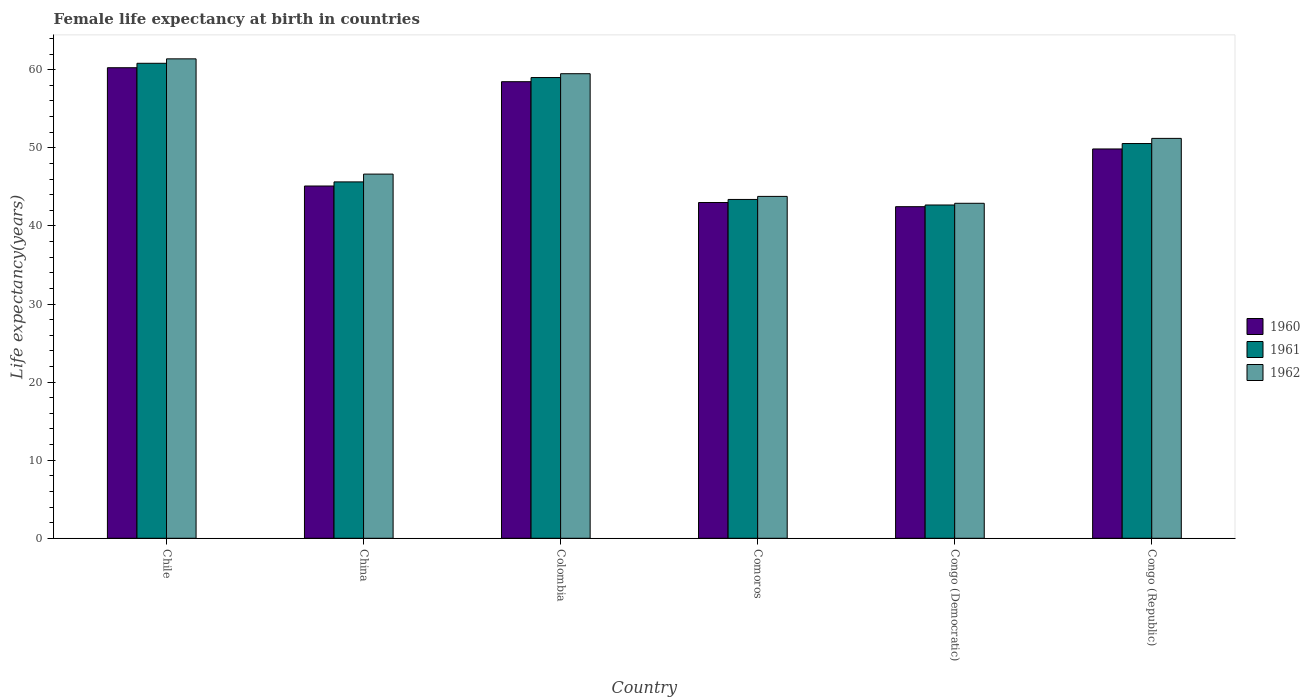How many groups of bars are there?
Make the answer very short. 6. How many bars are there on the 2nd tick from the right?
Provide a succinct answer. 3. What is the label of the 6th group of bars from the left?
Provide a short and direct response. Congo (Republic). What is the female life expectancy at birth in 1960 in Congo (Democratic)?
Provide a short and direct response. 42.47. Across all countries, what is the maximum female life expectancy at birth in 1961?
Offer a very short reply. 60.83. Across all countries, what is the minimum female life expectancy at birth in 1961?
Provide a short and direct response. 42.68. In which country was the female life expectancy at birth in 1960 maximum?
Your response must be concise. Chile. In which country was the female life expectancy at birth in 1962 minimum?
Your answer should be very brief. Congo (Democratic). What is the total female life expectancy at birth in 1962 in the graph?
Give a very brief answer. 305.42. What is the difference between the female life expectancy at birth in 1962 in China and that in Congo (Democratic)?
Offer a very short reply. 3.74. What is the difference between the female life expectancy at birth in 1962 in Comoros and the female life expectancy at birth in 1961 in Colombia?
Your answer should be compact. -15.22. What is the average female life expectancy at birth in 1960 per country?
Your answer should be compact. 49.86. What is the difference between the female life expectancy at birth of/in 1961 and female life expectancy at birth of/in 1960 in Comoros?
Give a very brief answer. 0.39. What is the ratio of the female life expectancy at birth in 1960 in Chile to that in China?
Provide a succinct answer. 1.34. Is the female life expectancy at birth in 1961 in Colombia less than that in Congo (Democratic)?
Make the answer very short. No. What is the difference between the highest and the second highest female life expectancy at birth in 1960?
Provide a succinct answer. -8.61. What is the difference between the highest and the lowest female life expectancy at birth in 1960?
Keep it short and to the point. 17.79. In how many countries, is the female life expectancy at birth in 1961 greater than the average female life expectancy at birth in 1961 taken over all countries?
Provide a short and direct response. 3. What does the 2nd bar from the left in China represents?
Your response must be concise. 1961. What does the 3rd bar from the right in Colombia represents?
Give a very brief answer. 1960. Is it the case that in every country, the sum of the female life expectancy at birth in 1961 and female life expectancy at birth in 1962 is greater than the female life expectancy at birth in 1960?
Give a very brief answer. Yes. How many bars are there?
Ensure brevity in your answer.  18. Are all the bars in the graph horizontal?
Your answer should be very brief. No. Are the values on the major ticks of Y-axis written in scientific E-notation?
Give a very brief answer. No. What is the title of the graph?
Keep it short and to the point. Female life expectancy at birth in countries. What is the label or title of the Y-axis?
Ensure brevity in your answer.  Life expectancy(years). What is the Life expectancy(years) in 1960 in Chile?
Offer a terse response. 60.26. What is the Life expectancy(years) in 1961 in Chile?
Provide a succinct answer. 60.83. What is the Life expectancy(years) of 1962 in Chile?
Provide a succinct answer. 61.4. What is the Life expectancy(years) in 1960 in China?
Your answer should be very brief. 45.11. What is the Life expectancy(years) of 1961 in China?
Keep it short and to the point. 45.64. What is the Life expectancy(years) of 1962 in China?
Provide a short and direct response. 46.64. What is the Life expectancy(years) of 1960 in Colombia?
Provide a short and direct response. 58.47. What is the Life expectancy(years) in 1961 in Colombia?
Keep it short and to the point. 59. What is the Life expectancy(years) in 1962 in Colombia?
Offer a terse response. 59.49. What is the Life expectancy(years) of 1960 in Comoros?
Your answer should be compact. 43. What is the Life expectancy(years) in 1961 in Comoros?
Keep it short and to the point. 43.39. What is the Life expectancy(years) of 1962 in Comoros?
Your response must be concise. 43.78. What is the Life expectancy(years) in 1960 in Congo (Democratic)?
Ensure brevity in your answer.  42.47. What is the Life expectancy(years) of 1961 in Congo (Democratic)?
Provide a succinct answer. 42.68. What is the Life expectancy(years) in 1962 in Congo (Democratic)?
Offer a very short reply. 42.9. What is the Life expectancy(years) in 1960 in Congo (Republic)?
Offer a very short reply. 49.86. What is the Life expectancy(years) of 1961 in Congo (Republic)?
Offer a terse response. 50.55. What is the Life expectancy(years) of 1962 in Congo (Republic)?
Provide a short and direct response. 51.21. Across all countries, what is the maximum Life expectancy(years) in 1960?
Keep it short and to the point. 60.26. Across all countries, what is the maximum Life expectancy(years) of 1961?
Make the answer very short. 60.83. Across all countries, what is the maximum Life expectancy(years) in 1962?
Offer a terse response. 61.4. Across all countries, what is the minimum Life expectancy(years) in 1960?
Offer a terse response. 42.47. Across all countries, what is the minimum Life expectancy(years) of 1961?
Your response must be concise. 42.68. Across all countries, what is the minimum Life expectancy(years) of 1962?
Keep it short and to the point. 42.9. What is the total Life expectancy(years) in 1960 in the graph?
Make the answer very short. 299.16. What is the total Life expectancy(years) of 1961 in the graph?
Keep it short and to the point. 302.09. What is the total Life expectancy(years) in 1962 in the graph?
Ensure brevity in your answer.  305.42. What is the difference between the Life expectancy(years) in 1960 in Chile and that in China?
Provide a succinct answer. 15.15. What is the difference between the Life expectancy(years) of 1961 in Chile and that in China?
Keep it short and to the point. 15.19. What is the difference between the Life expectancy(years) in 1962 in Chile and that in China?
Your answer should be very brief. 14.76. What is the difference between the Life expectancy(years) of 1960 in Chile and that in Colombia?
Give a very brief answer. 1.79. What is the difference between the Life expectancy(years) in 1961 in Chile and that in Colombia?
Ensure brevity in your answer.  1.83. What is the difference between the Life expectancy(years) in 1962 in Chile and that in Colombia?
Ensure brevity in your answer.  1.9. What is the difference between the Life expectancy(years) of 1960 in Chile and that in Comoros?
Ensure brevity in your answer.  17.26. What is the difference between the Life expectancy(years) of 1961 in Chile and that in Comoros?
Your answer should be compact. 17.44. What is the difference between the Life expectancy(years) in 1962 in Chile and that in Comoros?
Your answer should be very brief. 17.62. What is the difference between the Life expectancy(years) of 1960 in Chile and that in Congo (Democratic)?
Your answer should be very brief. 17.8. What is the difference between the Life expectancy(years) of 1961 in Chile and that in Congo (Democratic)?
Provide a short and direct response. 18.15. What is the difference between the Life expectancy(years) in 1962 in Chile and that in Congo (Democratic)?
Give a very brief answer. 18.5. What is the difference between the Life expectancy(years) in 1960 in Chile and that in Congo (Republic)?
Provide a succinct answer. 10.4. What is the difference between the Life expectancy(years) of 1961 in Chile and that in Congo (Republic)?
Provide a succinct answer. 10.28. What is the difference between the Life expectancy(years) in 1962 in Chile and that in Congo (Republic)?
Your response must be concise. 10.19. What is the difference between the Life expectancy(years) of 1960 in China and that in Colombia?
Provide a short and direct response. -13.36. What is the difference between the Life expectancy(years) of 1961 in China and that in Colombia?
Provide a short and direct response. -13.36. What is the difference between the Life expectancy(years) of 1962 in China and that in Colombia?
Your answer should be compact. -12.86. What is the difference between the Life expectancy(years) in 1960 in China and that in Comoros?
Ensure brevity in your answer.  2.11. What is the difference between the Life expectancy(years) in 1961 in China and that in Comoros?
Your answer should be very brief. 2.25. What is the difference between the Life expectancy(years) in 1962 in China and that in Comoros?
Your answer should be very brief. 2.86. What is the difference between the Life expectancy(years) in 1960 in China and that in Congo (Democratic)?
Provide a short and direct response. 2.65. What is the difference between the Life expectancy(years) in 1961 in China and that in Congo (Democratic)?
Your response must be concise. 2.96. What is the difference between the Life expectancy(years) in 1962 in China and that in Congo (Democratic)?
Provide a short and direct response. 3.74. What is the difference between the Life expectancy(years) in 1960 in China and that in Congo (Republic)?
Make the answer very short. -4.75. What is the difference between the Life expectancy(years) of 1961 in China and that in Congo (Republic)?
Offer a very short reply. -4.91. What is the difference between the Life expectancy(years) in 1962 in China and that in Congo (Republic)?
Ensure brevity in your answer.  -4.57. What is the difference between the Life expectancy(years) in 1960 in Colombia and that in Comoros?
Your answer should be very brief. 15.47. What is the difference between the Life expectancy(years) of 1961 in Colombia and that in Comoros?
Ensure brevity in your answer.  15.61. What is the difference between the Life expectancy(years) of 1962 in Colombia and that in Comoros?
Provide a short and direct response. 15.71. What is the difference between the Life expectancy(years) in 1960 in Colombia and that in Congo (Democratic)?
Your response must be concise. 16. What is the difference between the Life expectancy(years) of 1961 in Colombia and that in Congo (Democratic)?
Offer a terse response. 16.32. What is the difference between the Life expectancy(years) of 1962 in Colombia and that in Congo (Democratic)?
Ensure brevity in your answer.  16.59. What is the difference between the Life expectancy(years) in 1960 in Colombia and that in Congo (Republic)?
Provide a succinct answer. 8.61. What is the difference between the Life expectancy(years) of 1961 in Colombia and that in Congo (Republic)?
Keep it short and to the point. 8.45. What is the difference between the Life expectancy(years) in 1962 in Colombia and that in Congo (Republic)?
Provide a succinct answer. 8.28. What is the difference between the Life expectancy(years) of 1960 in Comoros and that in Congo (Democratic)?
Give a very brief answer. 0.53. What is the difference between the Life expectancy(years) of 1961 in Comoros and that in Congo (Democratic)?
Give a very brief answer. 0.71. What is the difference between the Life expectancy(years) of 1962 in Comoros and that in Congo (Democratic)?
Make the answer very short. 0.88. What is the difference between the Life expectancy(years) in 1960 in Comoros and that in Congo (Republic)?
Offer a terse response. -6.86. What is the difference between the Life expectancy(years) in 1961 in Comoros and that in Congo (Republic)?
Your response must be concise. -7.16. What is the difference between the Life expectancy(years) in 1962 in Comoros and that in Congo (Republic)?
Offer a very short reply. -7.43. What is the difference between the Life expectancy(years) of 1960 in Congo (Democratic) and that in Congo (Republic)?
Ensure brevity in your answer.  -7.39. What is the difference between the Life expectancy(years) in 1961 in Congo (Democratic) and that in Congo (Republic)?
Your answer should be very brief. -7.87. What is the difference between the Life expectancy(years) in 1962 in Congo (Democratic) and that in Congo (Republic)?
Give a very brief answer. -8.31. What is the difference between the Life expectancy(years) in 1960 in Chile and the Life expectancy(years) in 1961 in China?
Provide a short and direct response. 14.62. What is the difference between the Life expectancy(years) in 1960 in Chile and the Life expectancy(years) in 1962 in China?
Give a very brief answer. 13.62. What is the difference between the Life expectancy(years) in 1961 in Chile and the Life expectancy(years) in 1962 in China?
Ensure brevity in your answer.  14.19. What is the difference between the Life expectancy(years) in 1960 in Chile and the Life expectancy(years) in 1961 in Colombia?
Ensure brevity in your answer.  1.26. What is the difference between the Life expectancy(years) of 1960 in Chile and the Life expectancy(years) of 1962 in Colombia?
Give a very brief answer. 0.77. What is the difference between the Life expectancy(years) of 1961 in Chile and the Life expectancy(years) of 1962 in Colombia?
Ensure brevity in your answer.  1.33. What is the difference between the Life expectancy(years) in 1960 in Chile and the Life expectancy(years) in 1961 in Comoros?
Make the answer very short. 16.87. What is the difference between the Life expectancy(years) of 1960 in Chile and the Life expectancy(years) of 1962 in Comoros?
Your answer should be very brief. 16.48. What is the difference between the Life expectancy(years) in 1961 in Chile and the Life expectancy(years) in 1962 in Comoros?
Your answer should be compact. 17.05. What is the difference between the Life expectancy(years) of 1960 in Chile and the Life expectancy(years) of 1961 in Congo (Democratic)?
Give a very brief answer. 17.58. What is the difference between the Life expectancy(years) in 1960 in Chile and the Life expectancy(years) in 1962 in Congo (Democratic)?
Make the answer very short. 17.36. What is the difference between the Life expectancy(years) in 1961 in Chile and the Life expectancy(years) in 1962 in Congo (Democratic)?
Your answer should be compact. 17.93. What is the difference between the Life expectancy(years) in 1960 in Chile and the Life expectancy(years) in 1961 in Congo (Republic)?
Offer a terse response. 9.71. What is the difference between the Life expectancy(years) of 1960 in Chile and the Life expectancy(years) of 1962 in Congo (Republic)?
Give a very brief answer. 9.05. What is the difference between the Life expectancy(years) of 1961 in Chile and the Life expectancy(years) of 1962 in Congo (Republic)?
Provide a succinct answer. 9.62. What is the difference between the Life expectancy(years) in 1960 in China and the Life expectancy(years) in 1961 in Colombia?
Your answer should be compact. -13.89. What is the difference between the Life expectancy(years) in 1960 in China and the Life expectancy(years) in 1962 in Colombia?
Your answer should be very brief. -14.38. What is the difference between the Life expectancy(years) of 1961 in China and the Life expectancy(years) of 1962 in Colombia?
Your response must be concise. -13.86. What is the difference between the Life expectancy(years) of 1960 in China and the Life expectancy(years) of 1961 in Comoros?
Your answer should be very brief. 1.72. What is the difference between the Life expectancy(years) in 1960 in China and the Life expectancy(years) in 1962 in Comoros?
Offer a very short reply. 1.33. What is the difference between the Life expectancy(years) of 1961 in China and the Life expectancy(years) of 1962 in Comoros?
Your answer should be very brief. 1.86. What is the difference between the Life expectancy(years) of 1960 in China and the Life expectancy(years) of 1961 in Congo (Democratic)?
Ensure brevity in your answer.  2.43. What is the difference between the Life expectancy(years) of 1960 in China and the Life expectancy(years) of 1962 in Congo (Democratic)?
Make the answer very short. 2.21. What is the difference between the Life expectancy(years) in 1961 in China and the Life expectancy(years) in 1962 in Congo (Democratic)?
Offer a terse response. 2.74. What is the difference between the Life expectancy(years) of 1960 in China and the Life expectancy(years) of 1961 in Congo (Republic)?
Your answer should be very brief. -5.44. What is the difference between the Life expectancy(years) of 1960 in China and the Life expectancy(years) of 1962 in Congo (Republic)?
Make the answer very short. -6.1. What is the difference between the Life expectancy(years) in 1961 in China and the Life expectancy(years) in 1962 in Congo (Republic)?
Make the answer very short. -5.57. What is the difference between the Life expectancy(years) in 1960 in Colombia and the Life expectancy(years) in 1961 in Comoros?
Give a very brief answer. 15.08. What is the difference between the Life expectancy(years) of 1960 in Colombia and the Life expectancy(years) of 1962 in Comoros?
Your response must be concise. 14.69. What is the difference between the Life expectancy(years) of 1961 in Colombia and the Life expectancy(years) of 1962 in Comoros?
Offer a terse response. 15.22. What is the difference between the Life expectancy(years) in 1960 in Colombia and the Life expectancy(years) in 1961 in Congo (Democratic)?
Your answer should be compact. 15.79. What is the difference between the Life expectancy(years) of 1960 in Colombia and the Life expectancy(years) of 1962 in Congo (Democratic)?
Provide a short and direct response. 15.57. What is the difference between the Life expectancy(years) of 1961 in Colombia and the Life expectancy(years) of 1962 in Congo (Democratic)?
Offer a very short reply. 16.1. What is the difference between the Life expectancy(years) in 1960 in Colombia and the Life expectancy(years) in 1961 in Congo (Republic)?
Offer a terse response. 7.92. What is the difference between the Life expectancy(years) in 1960 in Colombia and the Life expectancy(years) in 1962 in Congo (Republic)?
Give a very brief answer. 7.26. What is the difference between the Life expectancy(years) of 1961 in Colombia and the Life expectancy(years) of 1962 in Congo (Republic)?
Ensure brevity in your answer.  7.79. What is the difference between the Life expectancy(years) in 1960 in Comoros and the Life expectancy(years) in 1961 in Congo (Democratic)?
Your answer should be compact. 0.32. What is the difference between the Life expectancy(years) in 1960 in Comoros and the Life expectancy(years) in 1962 in Congo (Democratic)?
Ensure brevity in your answer.  0.1. What is the difference between the Life expectancy(years) in 1961 in Comoros and the Life expectancy(years) in 1962 in Congo (Democratic)?
Your response must be concise. 0.49. What is the difference between the Life expectancy(years) in 1960 in Comoros and the Life expectancy(years) in 1961 in Congo (Republic)?
Make the answer very short. -7.55. What is the difference between the Life expectancy(years) of 1960 in Comoros and the Life expectancy(years) of 1962 in Congo (Republic)?
Offer a terse response. -8.21. What is the difference between the Life expectancy(years) in 1961 in Comoros and the Life expectancy(years) in 1962 in Congo (Republic)?
Keep it short and to the point. -7.82. What is the difference between the Life expectancy(years) of 1960 in Congo (Democratic) and the Life expectancy(years) of 1961 in Congo (Republic)?
Offer a terse response. -8.09. What is the difference between the Life expectancy(years) in 1960 in Congo (Democratic) and the Life expectancy(years) in 1962 in Congo (Republic)?
Give a very brief answer. -8.75. What is the difference between the Life expectancy(years) of 1961 in Congo (Democratic) and the Life expectancy(years) of 1962 in Congo (Republic)?
Give a very brief answer. -8.53. What is the average Life expectancy(years) of 1960 per country?
Your answer should be compact. 49.86. What is the average Life expectancy(years) in 1961 per country?
Your response must be concise. 50.35. What is the average Life expectancy(years) of 1962 per country?
Make the answer very short. 50.9. What is the difference between the Life expectancy(years) of 1960 and Life expectancy(years) of 1961 in Chile?
Ensure brevity in your answer.  -0.57. What is the difference between the Life expectancy(years) in 1960 and Life expectancy(years) in 1962 in Chile?
Give a very brief answer. -1.14. What is the difference between the Life expectancy(years) of 1961 and Life expectancy(years) of 1962 in Chile?
Offer a terse response. -0.57. What is the difference between the Life expectancy(years) of 1960 and Life expectancy(years) of 1961 in China?
Offer a very short reply. -0.53. What is the difference between the Life expectancy(years) in 1960 and Life expectancy(years) in 1962 in China?
Offer a terse response. -1.53. What is the difference between the Life expectancy(years) of 1961 and Life expectancy(years) of 1962 in China?
Give a very brief answer. -1. What is the difference between the Life expectancy(years) of 1960 and Life expectancy(years) of 1961 in Colombia?
Keep it short and to the point. -0.53. What is the difference between the Life expectancy(years) in 1960 and Life expectancy(years) in 1962 in Colombia?
Keep it short and to the point. -1.02. What is the difference between the Life expectancy(years) of 1961 and Life expectancy(years) of 1962 in Colombia?
Ensure brevity in your answer.  -0.49. What is the difference between the Life expectancy(years) in 1960 and Life expectancy(years) in 1961 in Comoros?
Your answer should be very brief. -0.39. What is the difference between the Life expectancy(years) of 1960 and Life expectancy(years) of 1962 in Comoros?
Your response must be concise. -0.78. What is the difference between the Life expectancy(years) of 1961 and Life expectancy(years) of 1962 in Comoros?
Offer a terse response. -0.39. What is the difference between the Life expectancy(years) of 1960 and Life expectancy(years) of 1961 in Congo (Democratic)?
Give a very brief answer. -0.22. What is the difference between the Life expectancy(years) of 1960 and Life expectancy(years) of 1962 in Congo (Democratic)?
Keep it short and to the point. -0.43. What is the difference between the Life expectancy(years) in 1961 and Life expectancy(years) in 1962 in Congo (Democratic)?
Your answer should be very brief. -0.22. What is the difference between the Life expectancy(years) in 1960 and Life expectancy(years) in 1961 in Congo (Republic)?
Offer a terse response. -0.69. What is the difference between the Life expectancy(years) of 1960 and Life expectancy(years) of 1962 in Congo (Republic)?
Provide a short and direct response. -1.35. What is the difference between the Life expectancy(years) in 1961 and Life expectancy(years) in 1962 in Congo (Republic)?
Keep it short and to the point. -0.66. What is the ratio of the Life expectancy(years) of 1960 in Chile to that in China?
Your response must be concise. 1.34. What is the ratio of the Life expectancy(years) in 1961 in Chile to that in China?
Your answer should be compact. 1.33. What is the ratio of the Life expectancy(years) of 1962 in Chile to that in China?
Make the answer very short. 1.32. What is the ratio of the Life expectancy(years) in 1960 in Chile to that in Colombia?
Your answer should be compact. 1.03. What is the ratio of the Life expectancy(years) of 1961 in Chile to that in Colombia?
Make the answer very short. 1.03. What is the ratio of the Life expectancy(years) of 1962 in Chile to that in Colombia?
Your answer should be very brief. 1.03. What is the ratio of the Life expectancy(years) of 1960 in Chile to that in Comoros?
Give a very brief answer. 1.4. What is the ratio of the Life expectancy(years) in 1961 in Chile to that in Comoros?
Make the answer very short. 1.4. What is the ratio of the Life expectancy(years) of 1962 in Chile to that in Comoros?
Give a very brief answer. 1.4. What is the ratio of the Life expectancy(years) in 1960 in Chile to that in Congo (Democratic)?
Ensure brevity in your answer.  1.42. What is the ratio of the Life expectancy(years) in 1961 in Chile to that in Congo (Democratic)?
Your answer should be compact. 1.43. What is the ratio of the Life expectancy(years) of 1962 in Chile to that in Congo (Democratic)?
Your answer should be compact. 1.43. What is the ratio of the Life expectancy(years) in 1960 in Chile to that in Congo (Republic)?
Ensure brevity in your answer.  1.21. What is the ratio of the Life expectancy(years) in 1961 in Chile to that in Congo (Republic)?
Provide a short and direct response. 1.2. What is the ratio of the Life expectancy(years) of 1962 in Chile to that in Congo (Republic)?
Your response must be concise. 1.2. What is the ratio of the Life expectancy(years) in 1960 in China to that in Colombia?
Offer a terse response. 0.77. What is the ratio of the Life expectancy(years) in 1961 in China to that in Colombia?
Your response must be concise. 0.77. What is the ratio of the Life expectancy(years) of 1962 in China to that in Colombia?
Offer a terse response. 0.78. What is the ratio of the Life expectancy(years) of 1960 in China to that in Comoros?
Give a very brief answer. 1.05. What is the ratio of the Life expectancy(years) in 1961 in China to that in Comoros?
Your answer should be very brief. 1.05. What is the ratio of the Life expectancy(years) in 1962 in China to that in Comoros?
Ensure brevity in your answer.  1.07. What is the ratio of the Life expectancy(years) of 1960 in China to that in Congo (Democratic)?
Give a very brief answer. 1.06. What is the ratio of the Life expectancy(years) in 1961 in China to that in Congo (Democratic)?
Make the answer very short. 1.07. What is the ratio of the Life expectancy(years) of 1962 in China to that in Congo (Democratic)?
Ensure brevity in your answer.  1.09. What is the ratio of the Life expectancy(years) in 1960 in China to that in Congo (Republic)?
Your answer should be compact. 0.9. What is the ratio of the Life expectancy(years) of 1961 in China to that in Congo (Republic)?
Ensure brevity in your answer.  0.9. What is the ratio of the Life expectancy(years) in 1962 in China to that in Congo (Republic)?
Give a very brief answer. 0.91. What is the ratio of the Life expectancy(years) in 1960 in Colombia to that in Comoros?
Your answer should be compact. 1.36. What is the ratio of the Life expectancy(years) in 1961 in Colombia to that in Comoros?
Provide a short and direct response. 1.36. What is the ratio of the Life expectancy(years) of 1962 in Colombia to that in Comoros?
Give a very brief answer. 1.36. What is the ratio of the Life expectancy(years) of 1960 in Colombia to that in Congo (Democratic)?
Offer a very short reply. 1.38. What is the ratio of the Life expectancy(years) of 1961 in Colombia to that in Congo (Democratic)?
Your response must be concise. 1.38. What is the ratio of the Life expectancy(years) of 1962 in Colombia to that in Congo (Democratic)?
Your answer should be very brief. 1.39. What is the ratio of the Life expectancy(years) of 1960 in Colombia to that in Congo (Republic)?
Make the answer very short. 1.17. What is the ratio of the Life expectancy(years) of 1961 in Colombia to that in Congo (Republic)?
Make the answer very short. 1.17. What is the ratio of the Life expectancy(years) of 1962 in Colombia to that in Congo (Republic)?
Make the answer very short. 1.16. What is the ratio of the Life expectancy(years) in 1960 in Comoros to that in Congo (Democratic)?
Ensure brevity in your answer.  1.01. What is the ratio of the Life expectancy(years) of 1961 in Comoros to that in Congo (Democratic)?
Provide a succinct answer. 1.02. What is the ratio of the Life expectancy(years) of 1962 in Comoros to that in Congo (Democratic)?
Keep it short and to the point. 1.02. What is the ratio of the Life expectancy(years) in 1960 in Comoros to that in Congo (Republic)?
Your response must be concise. 0.86. What is the ratio of the Life expectancy(years) of 1961 in Comoros to that in Congo (Republic)?
Offer a terse response. 0.86. What is the ratio of the Life expectancy(years) of 1962 in Comoros to that in Congo (Republic)?
Your answer should be very brief. 0.85. What is the ratio of the Life expectancy(years) in 1960 in Congo (Democratic) to that in Congo (Republic)?
Make the answer very short. 0.85. What is the ratio of the Life expectancy(years) in 1961 in Congo (Democratic) to that in Congo (Republic)?
Keep it short and to the point. 0.84. What is the ratio of the Life expectancy(years) of 1962 in Congo (Democratic) to that in Congo (Republic)?
Give a very brief answer. 0.84. What is the difference between the highest and the second highest Life expectancy(years) in 1960?
Your answer should be very brief. 1.79. What is the difference between the highest and the second highest Life expectancy(years) in 1961?
Keep it short and to the point. 1.83. What is the difference between the highest and the second highest Life expectancy(years) of 1962?
Make the answer very short. 1.9. What is the difference between the highest and the lowest Life expectancy(years) in 1960?
Give a very brief answer. 17.8. What is the difference between the highest and the lowest Life expectancy(years) in 1961?
Make the answer very short. 18.15. What is the difference between the highest and the lowest Life expectancy(years) in 1962?
Provide a short and direct response. 18.5. 